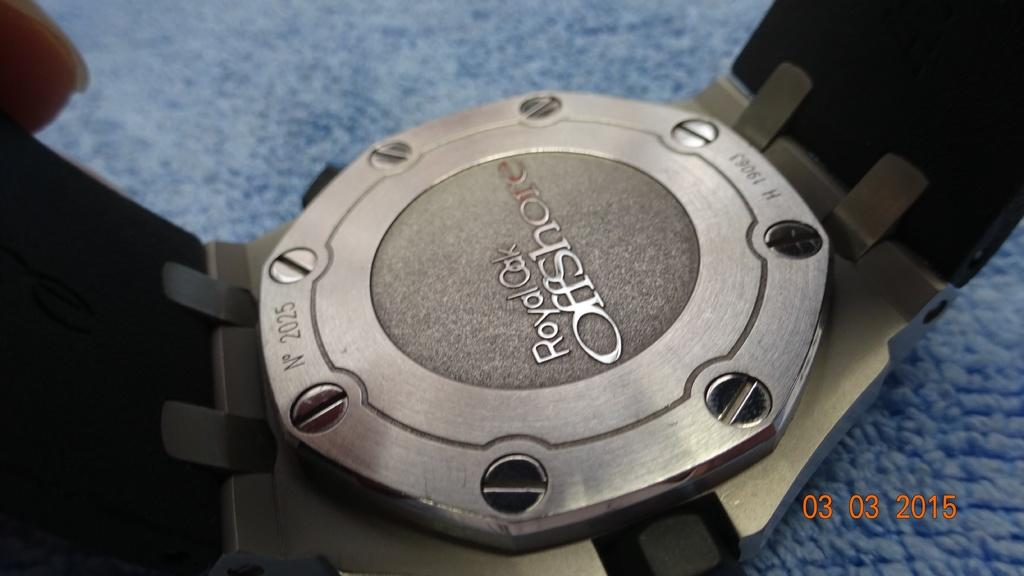<image>
Present a compact description of the photo's key features. the back side of a royal oak offshore watch. 